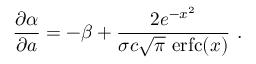Convert formula to latex. <formula><loc_0><loc_0><loc_500><loc_500>\frac { \partial \alpha } { \partial a } = - \beta + \frac { 2 e ^ { - x ^ { 2 } } } { \sigma c \sqrt { \pi } \ e r f c ( x ) } \ .</formula> 